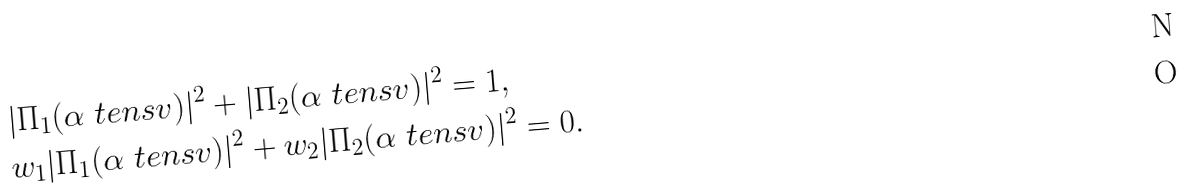<formula> <loc_0><loc_0><loc_500><loc_500>& | \Pi _ { 1 } ( \alpha \ t e n s v ) | ^ { 2 } + | \Pi _ { 2 } ( \alpha \ t e n s v ) | ^ { 2 } = 1 , \\ & w _ { 1 } | \Pi _ { 1 } ( \alpha \ t e n s v ) | ^ { 2 } + w _ { 2 } | \Pi _ { 2 } ( \alpha \ t e n s v ) | ^ { 2 } = 0 .</formula> 